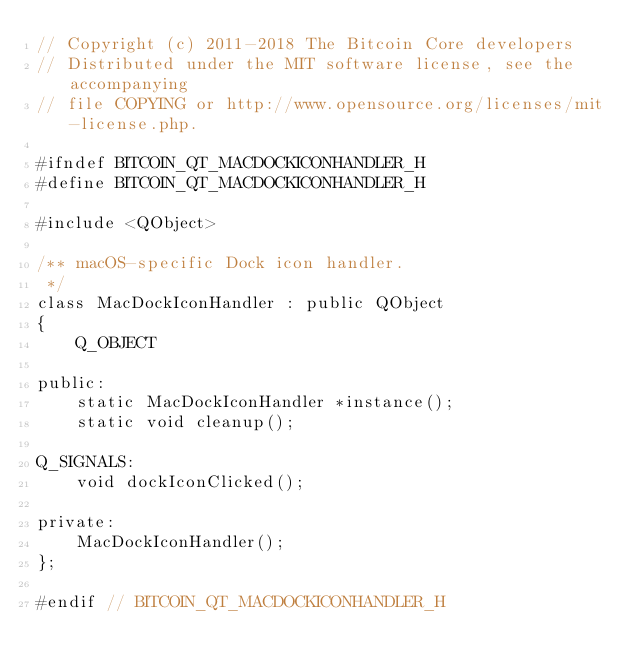<code> <loc_0><loc_0><loc_500><loc_500><_C_>// Copyright (c) 2011-2018 The Bitcoin Core developers
// Distributed under the MIT software license, see the accompanying
// file COPYING or http://www.opensource.org/licenses/mit-license.php.

#ifndef BITCOIN_QT_MACDOCKICONHANDLER_H
#define BITCOIN_QT_MACDOCKICONHANDLER_H

#include <QObject>

/** macOS-specific Dock icon handler.
 */
class MacDockIconHandler : public QObject
{
    Q_OBJECT

public:
    static MacDockIconHandler *instance();
    static void cleanup();

Q_SIGNALS:
    void dockIconClicked();

private:
    MacDockIconHandler();
};

#endif // BITCOIN_QT_MACDOCKICONHANDLER_H
</code> 